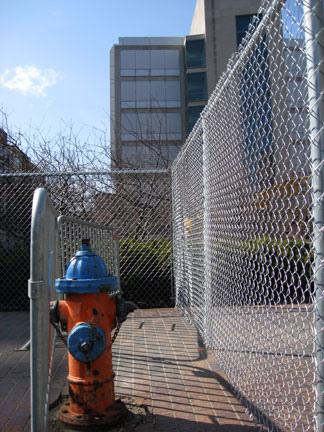Is the fence high?
Concise answer only. Yes. Is this an urban area?
Be succinct. Yes. What color is the fire hydrant?
Concise answer only. Orange and blue. 